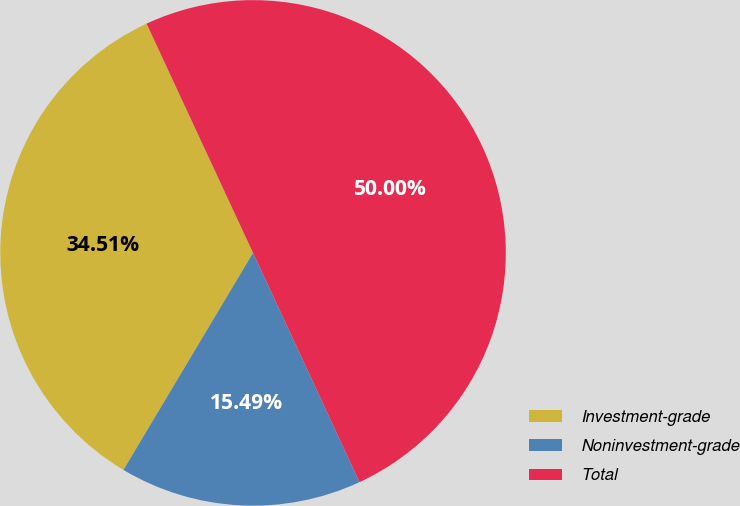Convert chart. <chart><loc_0><loc_0><loc_500><loc_500><pie_chart><fcel>Investment-grade<fcel>Noninvestment-grade<fcel>Total<nl><fcel>34.51%<fcel>15.49%<fcel>50.0%<nl></chart> 